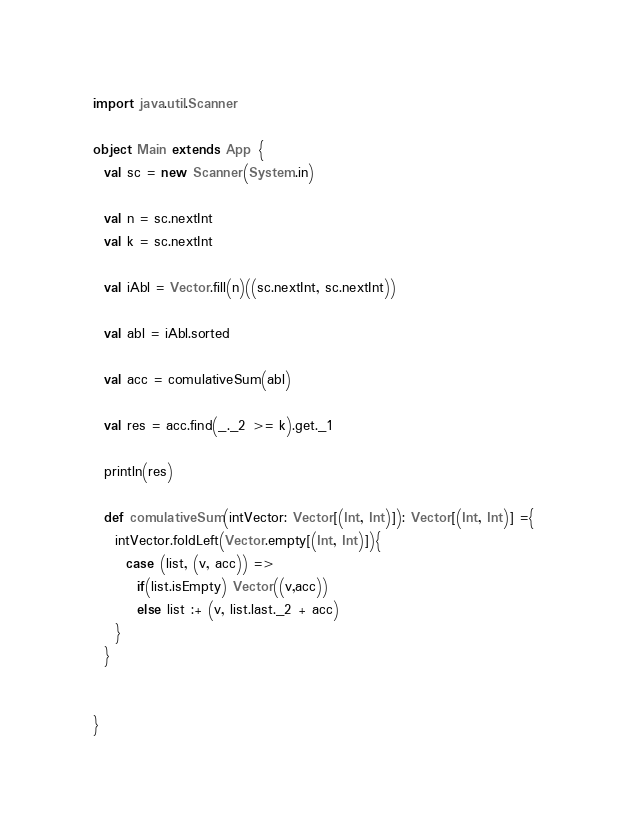Convert code to text. <code><loc_0><loc_0><loc_500><loc_500><_Scala_>import java.util.Scanner

object Main extends App {
  val sc = new Scanner(System.in)

  val n = sc.nextInt
  val k = sc.nextInt

  val iAbl = Vector.fill(n)((sc.nextInt, sc.nextInt))

  val abl = iAbl.sorted

  val acc = comulativeSum(abl)
  
  val res = acc.find(_._2 >= k).get._1

  println(res)

  def comulativeSum(intVector: Vector[(Int, Int)]): Vector[(Int, Int)] ={
    intVector.foldLeft(Vector.empty[(Int, Int)]){
      case (list, (v, acc)) =>
        if(list.isEmpty) Vector((v,acc))
        else list :+ (v, list.last._2 + acc)
    }
  }


}
</code> 